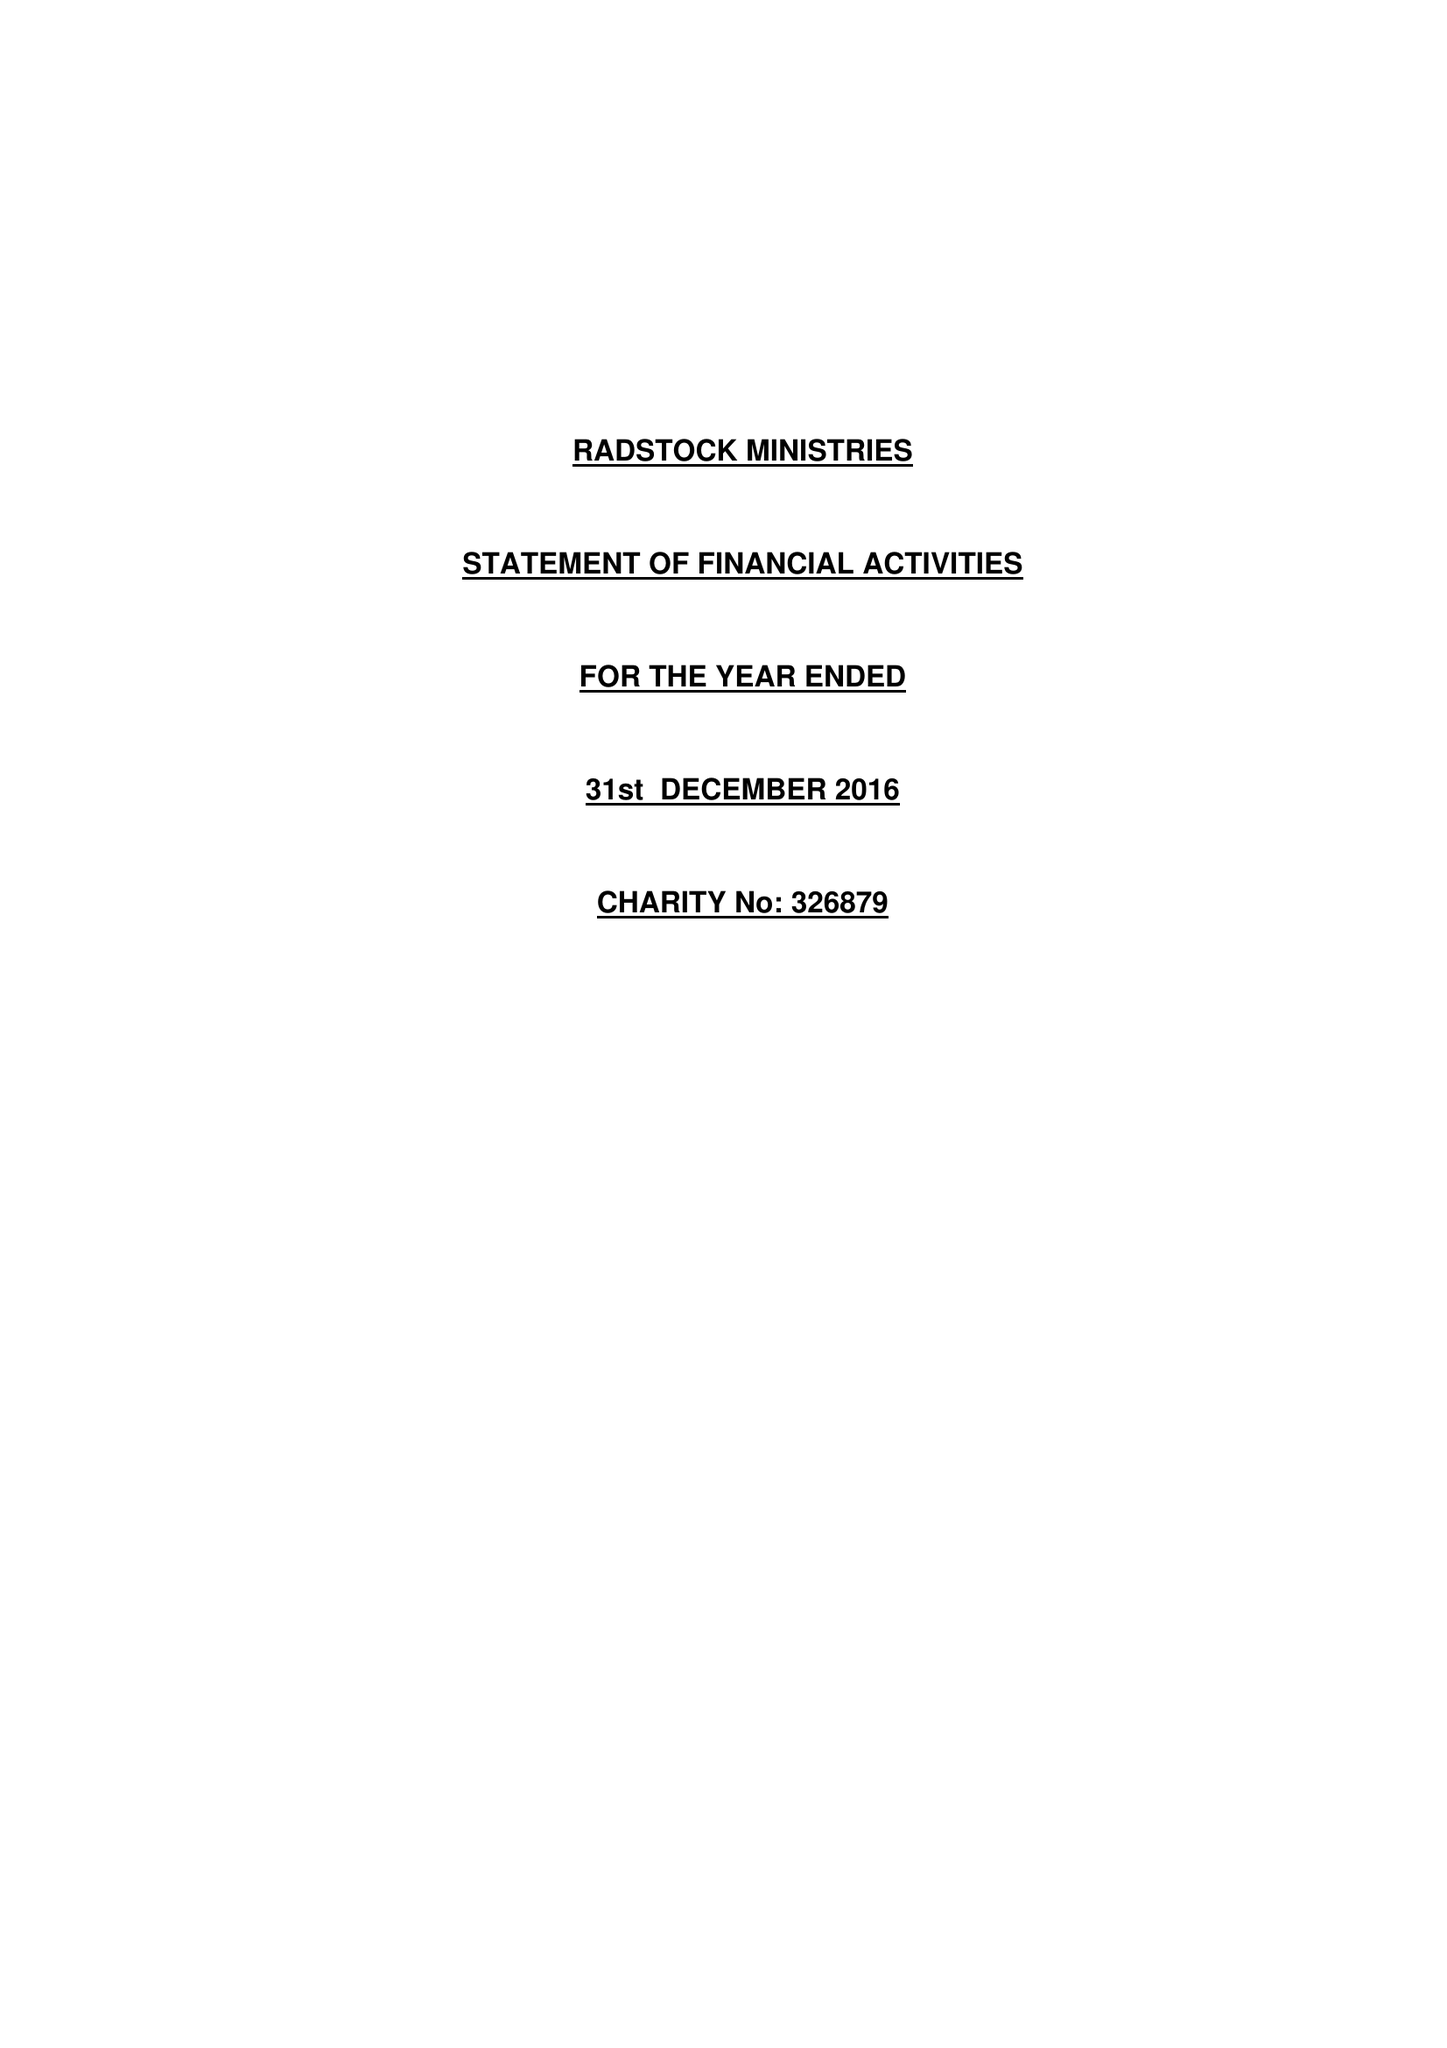What is the value for the address__post_town?
Answer the question using a single word or phrase. LUTON 